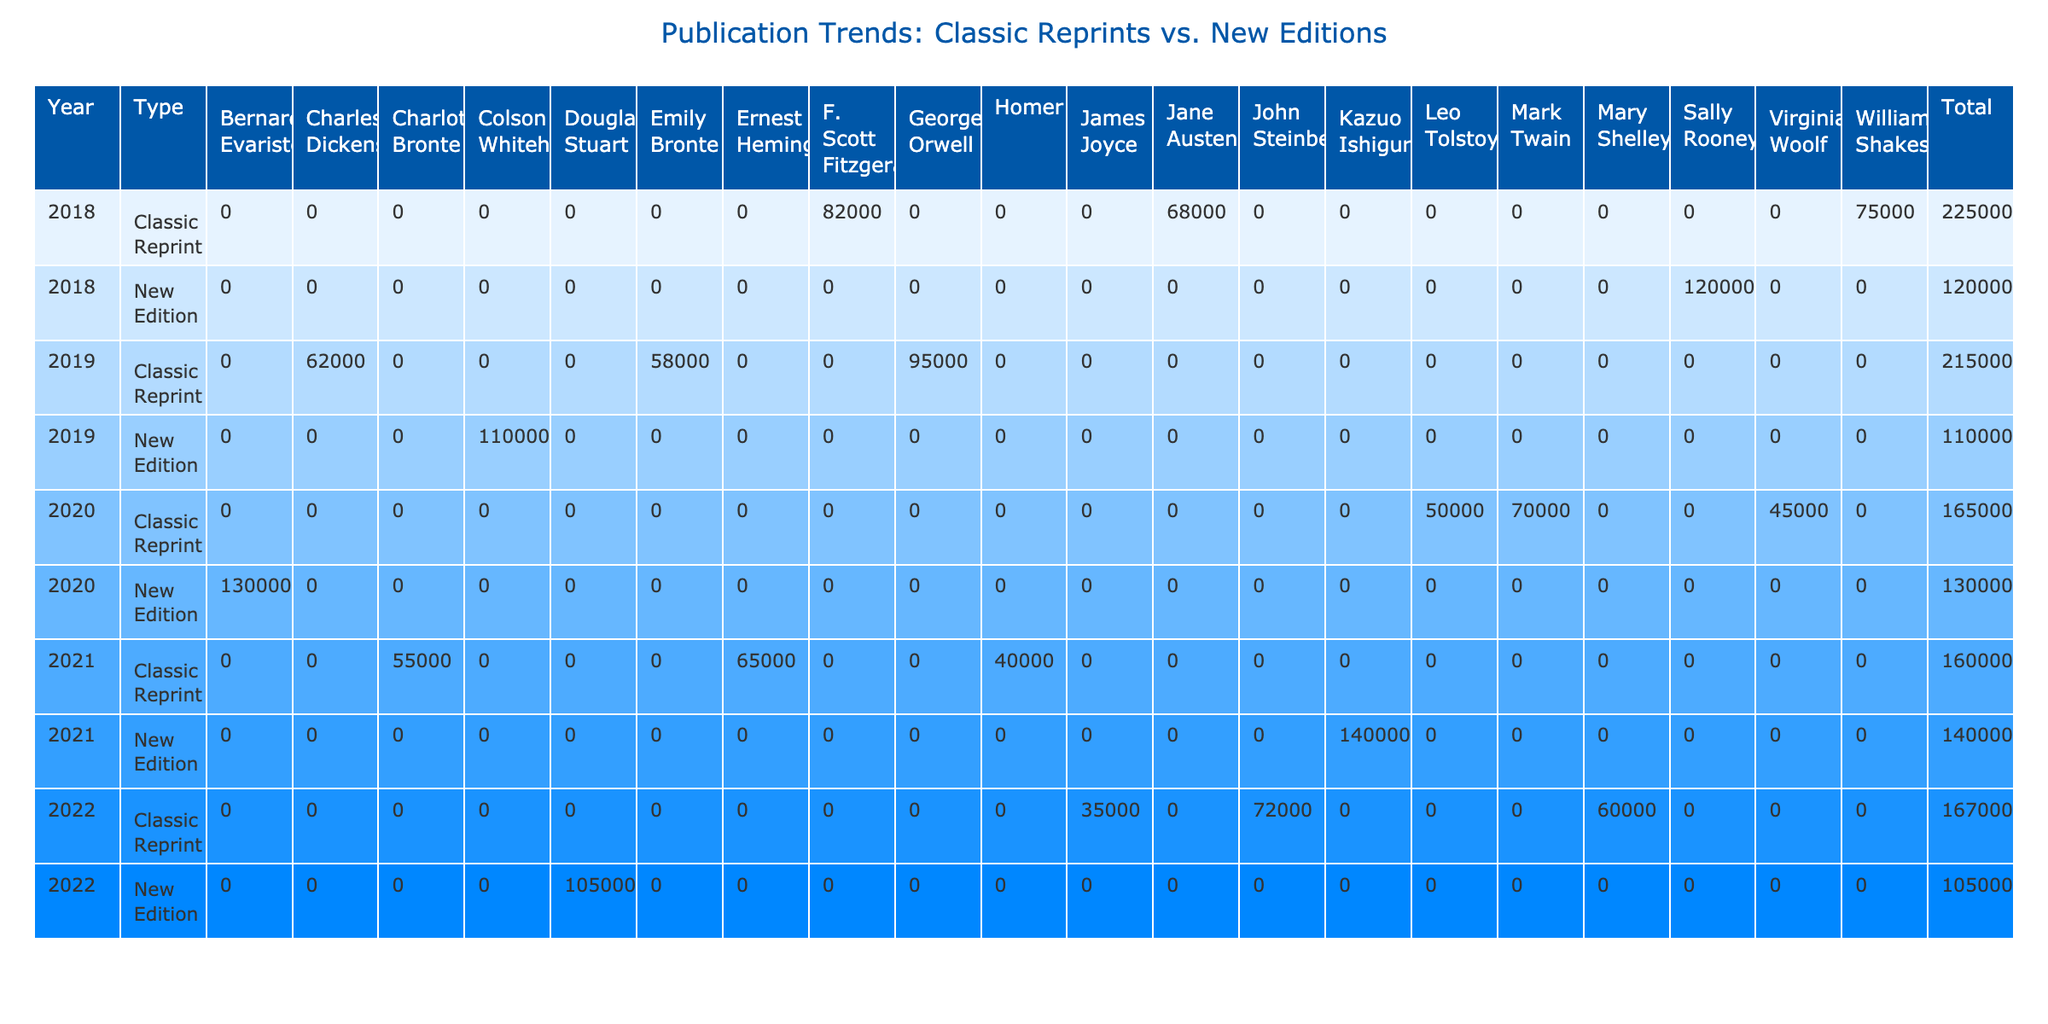What is the total units sold for classic reprints in 2018? Referring to the table, the units sold for classic reprints in 2018 are: Hamlet (75000), Pride and Prejudice (68000), and The Great Gatsby (82000). Adding these gives: 75000 + 68000 + 82000 = 225000.
Answer: 225000 Which author had the highest units sold in new editions? Looking at the new editions, the authors and their units sold are: Normal People (120000), The Nickel Boys (110000), Girl Woman Other (130000), and Klara and the Sun (140000). Among these, Klara and the Sun has the highest units at 140000.
Answer: Klara and the Sun What is the difference in units sold between classic reprints and new editions in 2022? From the table for 2022, classic reprints sold: Of Mice and Men (72000), Frankenstein (60000), and Ulysses (35000), giving a total of: 72000 + 60000 + 35000 = 167000. New editions sold: Young Mungo (105000). The difference is 167000 - 105000 = 62000.
Answer: 62000 Did any new edition surpass the total units sold of classic reprints in 2019? For 2019, classic reprints sold: Great Expectations (62000), Wuthering Heights (58000), and 1984 (95000), totaling: 62000 + 58000 + 95000 = 215000. The new edition sold The Nickel Boys with 110000. Since 110000 is less than 215000, no new edition surpassed the total.
Answer: No What was the average units sold for classic reprints across all years? Summing the units sold for classic reprints: 75000 + 68000 + 82000 + 62000 + 58000 + 95000 + 50000 + 45000 + 70000 + 40000 + 55000 + 65000 + 72000 + 60000 + 35000 = 778000. There are 15 classic reprints so, the average is 778000 / 15 = 51866.67, rounded approximately gives 51867.
Answer: 51867 